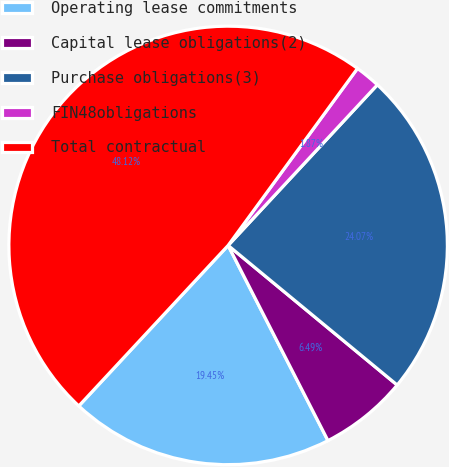<chart> <loc_0><loc_0><loc_500><loc_500><pie_chart><fcel>Operating lease commitments<fcel>Capital lease obligations(2)<fcel>Purchase obligations(3)<fcel>FIN48obligations<fcel>Total contractual<nl><fcel>19.45%<fcel>6.49%<fcel>24.07%<fcel>1.87%<fcel>48.12%<nl></chart> 